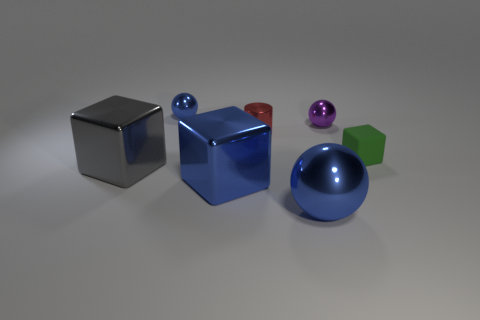Subtract all tiny spheres. How many spheres are left? 1 Add 1 blue spheres. How many objects exist? 8 Subtract 1 balls. How many balls are left? 2 Subtract all balls. How many objects are left? 4 Add 4 tiny green objects. How many tiny green objects are left? 5 Add 4 small red metallic cylinders. How many small red metallic cylinders exist? 5 Subtract 0 green cylinders. How many objects are left? 7 Subtract all metallic objects. Subtract all matte objects. How many objects are left? 0 